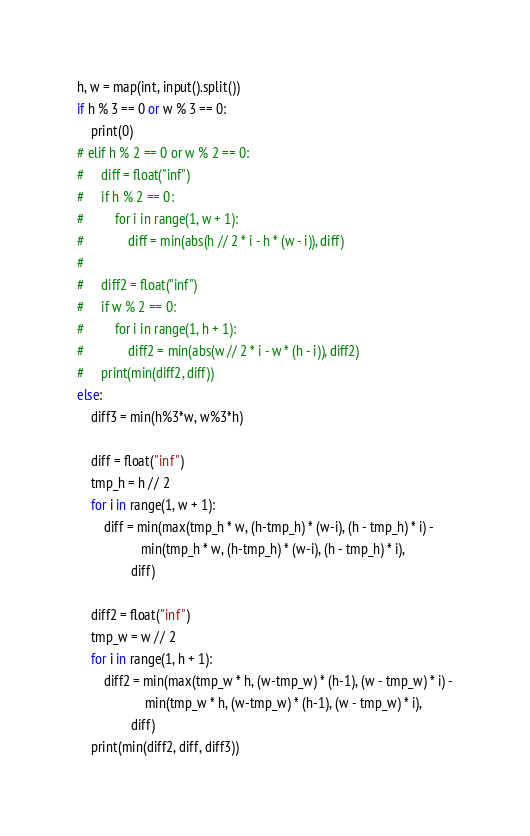Convert code to text. <code><loc_0><loc_0><loc_500><loc_500><_Python_>h, w = map(int, input().split())
if h % 3 == 0 or w % 3 == 0:
    print(0)
# elif h % 2 == 0 or w % 2 == 0:
#     diff = float("inf")
#     if h % 2 == 0:
#         for i in range(1, w + 1):
#             diff = min(abs(h // 2 * i - h * (w - i)), diff)
#
#     diff2 = float("inf")
#     if w % 2 == 0:
#         for i in range(1, h + 1):
#             diff2 = min(abs(w // 2 * i - w * (h - i)), diff2)
#     print(min(diff2, diff))
else:
    diff3 = min(h%3*w, w%3*h)

    diff = float("inf")
    tmp_h = h // 2
    for i in range(1, w + 1):
        diff = min(max(tmp_h * w, (h-tmp_h) * (w-i), (h - tmp_h) * i) -
                   min(tmp_h * w, (h-tmp_h) * (w-i), (h - tmp_h) * i),
                diff)

    diff2 = float("inf")
    tmp_w = w // 2
    for i in range(1, h + 1):
        diff2 = min(max(tmp_w * h, (w-tmp_w) * (h-1), (w - tmp_w) * i) -
                    min(tmp_w * h, (w-tmp_w) * (h-1), (w - tmp_w) * i),
                diff)
    print(min(diff2, diff, diff3))
</code> 